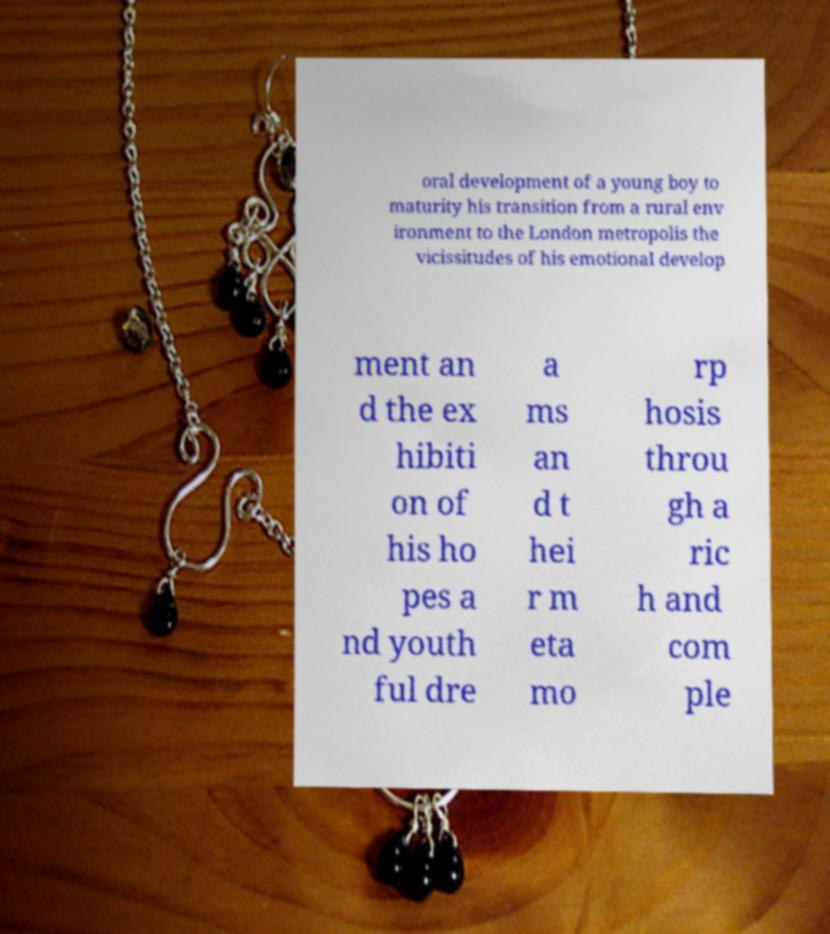There's text embedded in this image that I need extracted. Can you transcribe it verbatim? oral development of a young boy to maturity his transition from a rural env ironment to the London metropolis the vicissitudes of his emotional develop ment an d the ex hibiti on of his ho pes a nd youth ful dre a ms an d t hei r m eta mo rp hosis throu gh a ric h and com ple 